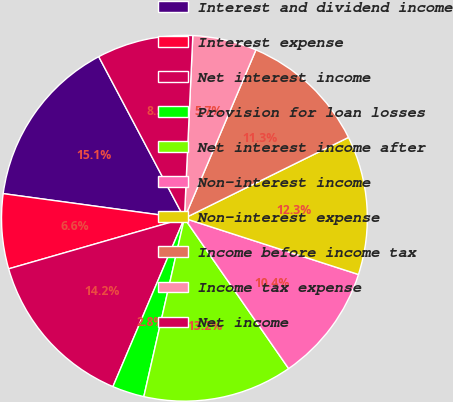<chart> <loc_0><loc_0><loc_500><loc_500><pie_chart><fcel>Interest and dividend income<fcel>Interest expense<fcel>Net interest income<fcel>Provision for loan losses<fcel>Net interest income after<fcel>Non-interest income<fcel>Non-interest expense<fcel>Income before income tax<fcel>Income tax expense<fcel>Net income<nl><fcel>15.09%<fcel>6.61%<fcel>14.15%<fcel>2.83%<fcel>13.21%<fcel>10.38%<fcel>12.26%<fcel>11.32%<fcel>5.66%<fcel>8.49%<nl></chart> 